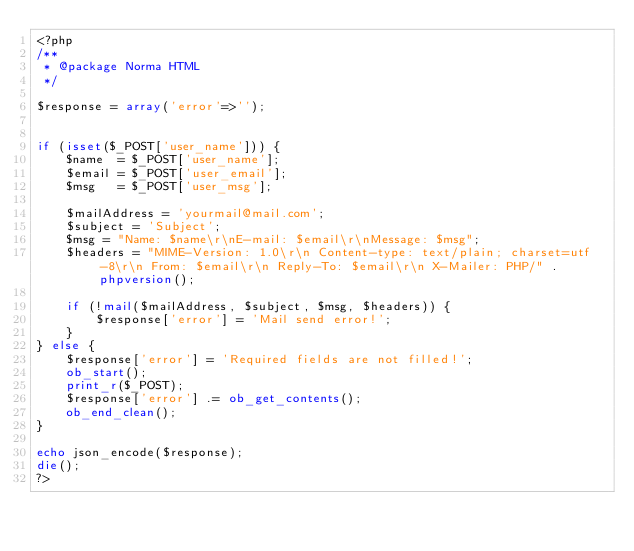<code> <loc_0><loc_0><loc_500><loc_500><_PHP_><?php 
/**
 * @package Norma HTML
 */

$response = array('error'=>'');


if (isset($_POST['user_name'])) {
	$name  = $_POST['user_name'];
	$email = $_POST['user_email'];
	$msg   = $_POST['user_msg'];
	
	$mailAddress = 'yourmail@mail.com';
	$subject = 'Subject';
	$msg = "Name: $name\r\nE-mail: $email\r\nMessage: $msg";
	$headers = "MIME-Version: 1.0\r\n Content-type: text/plain; charset=utf-8\r\n From: $email\r\n Reply-To: $email\r\n X-Mailer: PHP/" . phpversion();
	
	if (!mail($mailAddress, $subject, $msg, $headers)) {
		$response['error'] = 'Mail send error!';
	}
} else {
	$response['error'] = 'Required fields are not filled!';
	ob_start();
	print_r($_POST);
	$response['error'] .= ob_get_contents();
	ob_end_clean();
}

echo json_encode($response);
die();
?></code> 